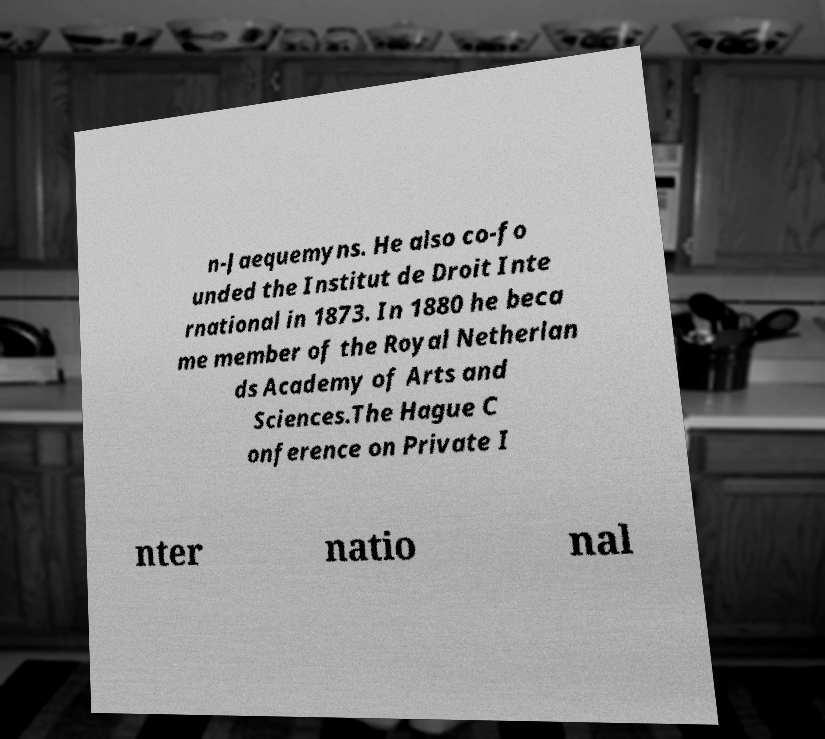What messages or text are displayed in this image? I need them in a readable, typed format. n-Jaequemyns. He also co-fo unded the Institut de Droit Inte rnational in 1873. In 1880 he beca me member of the Royal Netherlan ds Academy of Arts and Sciences.The Hague C onference on Private I nter natio nal 